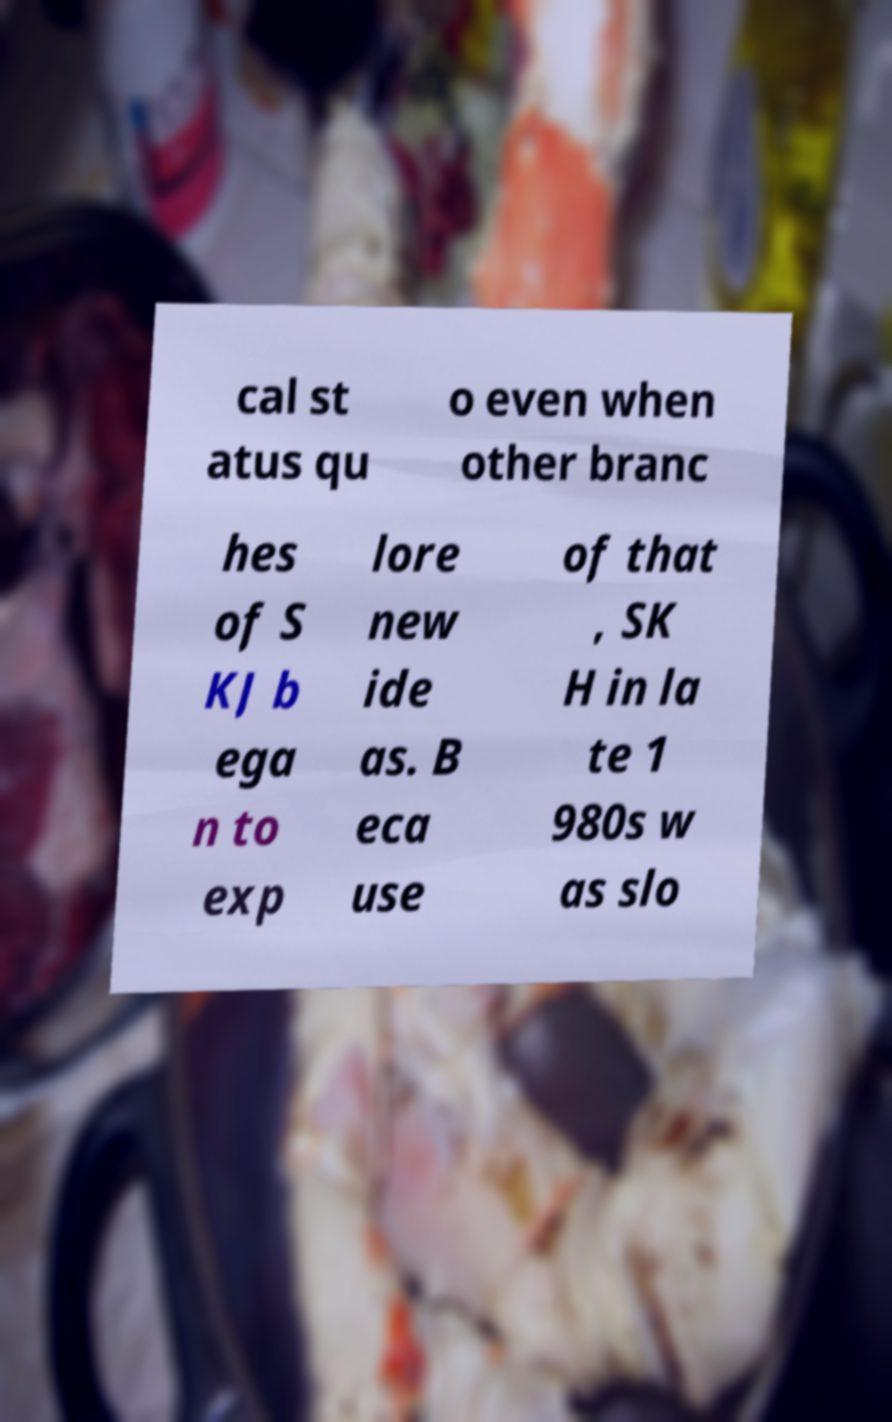There's text embedded in this image that I need extracted. Can you transcribe it verbatim? cal st atus qu o even when other branc hes of S KJ b ega n to exp lore new ide as. B eca use of that , SK H in la te 1 980s w as slo 